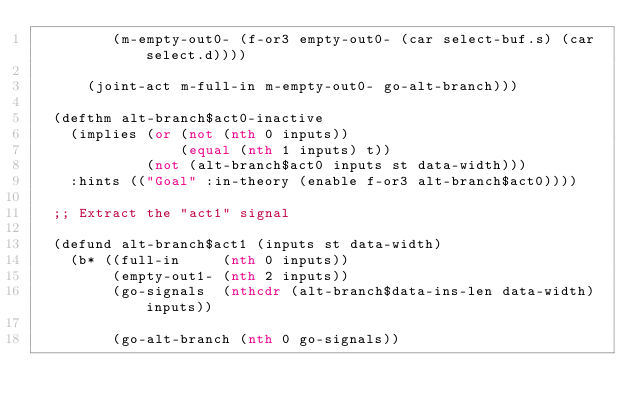Convert code to text. <code><loc_0><loc_0><loc_500><loc_500><_Lisp_>         (m-empty-out0- (f-or3 empty-out0- (car select-buf.s) (car select.d))))

      (joint-act m-full-in m-empty-out0- go-alt-branch)))

  (defthm alt-branch$act0-inactive
    (implies (or (not (nth 0 inputs))
                 (equal (nth 1 inputs) t))
             (not (alt-branch$act0 inputs st data-width)))
    :hints (("Goal" :in-theory (enable f-or3 alt-branch$act0))))

  ;; Extract the "act1" signal

  (defund alt-branch$act1 (inputs st data-width)
    (b* ((full-in     (nth 0 inputs))
         (empty-out1- (nth 2 inputs))
         (go-signals  (nthcdr (alt-branch$data-ins-len data-width) inputs))

         (go-alt-branch (nth 0 go-signals))
</code> 